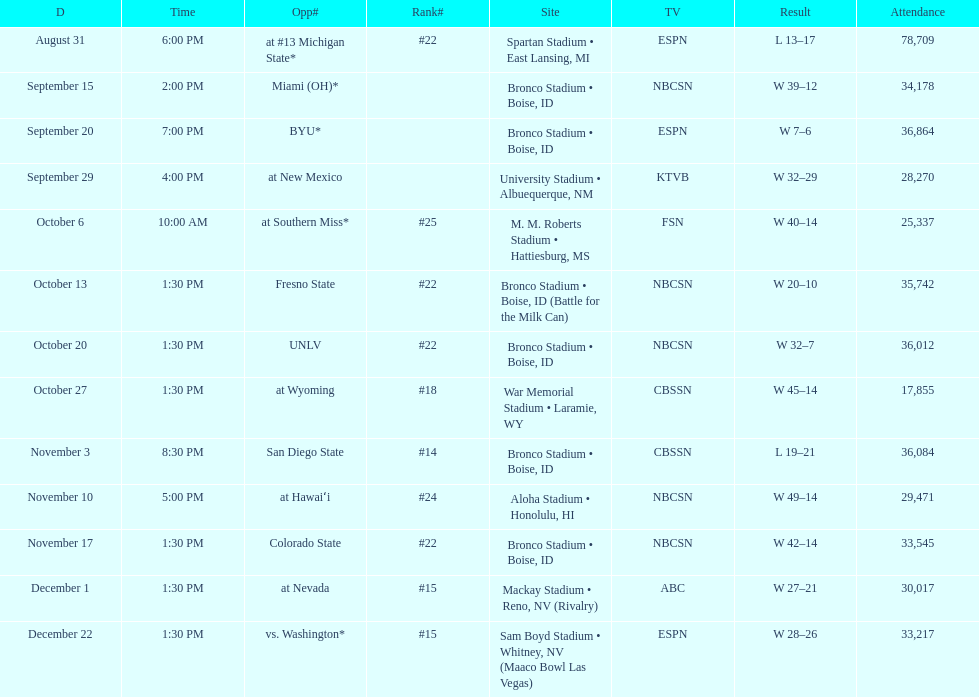Add up the total number of points scored in the last wins for boise state. 146. Can you give me this table as a dict? {'header': ['D', 'Time', 'Opp#', 'Rank#', 'Site', 'TV', 'Result', 'Attendance'], 'rows': [['August 31', '6:00 PM', 'at\xa0#13\xa0Michigan State*', '#22', 'Spartan Stadium • East Lansing, MI', 'ESPN', 'L\xa013–17', '78,709'], ['September 15', '2:00 PM', 'Miami (OH)*', '', 'Bronco Stadium • Boise, ID', 'NBCSN', 'W\xa039–12', '34,178'], ['September 20', '7:00 PM', 'BYU*', '', 'Bronco Stadium • Boise, ID', 'ESPN', 'W\xa07–6', '36,864'], ['September 29', '4:00 PM', 'at\xa0New Mexico', '', 'University Stadium • Albuequerque, NM', 'KTVB', 'W\xa032–29', '28,270'], ['October 6', '10:00 AM', 'at\xa0Southern Miss*', '#25', 'M. M. Roberts Stadium • Hattiesburg, MS', 'FSN', 'W\xa040–14', '25,337'], ['October 13', '1:30 PM', 'Fresno State', '#22', 'Bronco Stadium • Boise, ID (Battle for the Milk Can)', 'NBCSN', 'W\xa020–10', '35,742'], ['October 20', '1:30 PM', 'UNLV', '#22', 'Bronco Stadium • Boise, ID', 'NBCSN', 'W\xa032–7', '36,012'], ['October 27', '1:30 PM', 'at\xa0Wyoming', '#18', 'War Memorial Stadium • Laramie, WY', 'CBSSN', 'W\xa045–14', '17,855'], ['November 3', '8:30 PM', 'San Diego State', '#14', 'Bronco Stadium • Boise, ID', 'CBSSN', 'L\xa019–21', '36,084'], ['November 10', '5:00 PM', 'at\xa0Hawaiʻi', '#24', 'Aloha Stadium • Honolulu, HI', 'NBCSN', 'W\xa049–14', '29,471'], ['November 17', '1:30 PM', 'Colorado State', '#22', 'Bronco Stadium • Boise, ID', 'NBCSN', 'W\xa042–14', '33,545'], ['December 1', '1:30 PM', 'at\xa0Nevada', '#15', 'Mackay Stadium • Reno, NV (Rivalry)', 'ABC', 'W\xa027–21', '30,017'], ['December 22', '1:30 PM', 'vs.\xa0Washington*', '#15', 'Sam Boyd Stadium • Whitney, NV (Maaco Bowl Las Vegas)', 'ESPN', 'W\xa028–26', '33,217']]} 